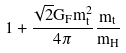<formula> <loc_0><loc_0><loc_500><loc_500>1 + \frac { \sqrt { 2 } G _ { F } m _ { t } ^ { 2 } } { 4 \pi } \frac { m _ { t } } { m _ { H } }</formula> 